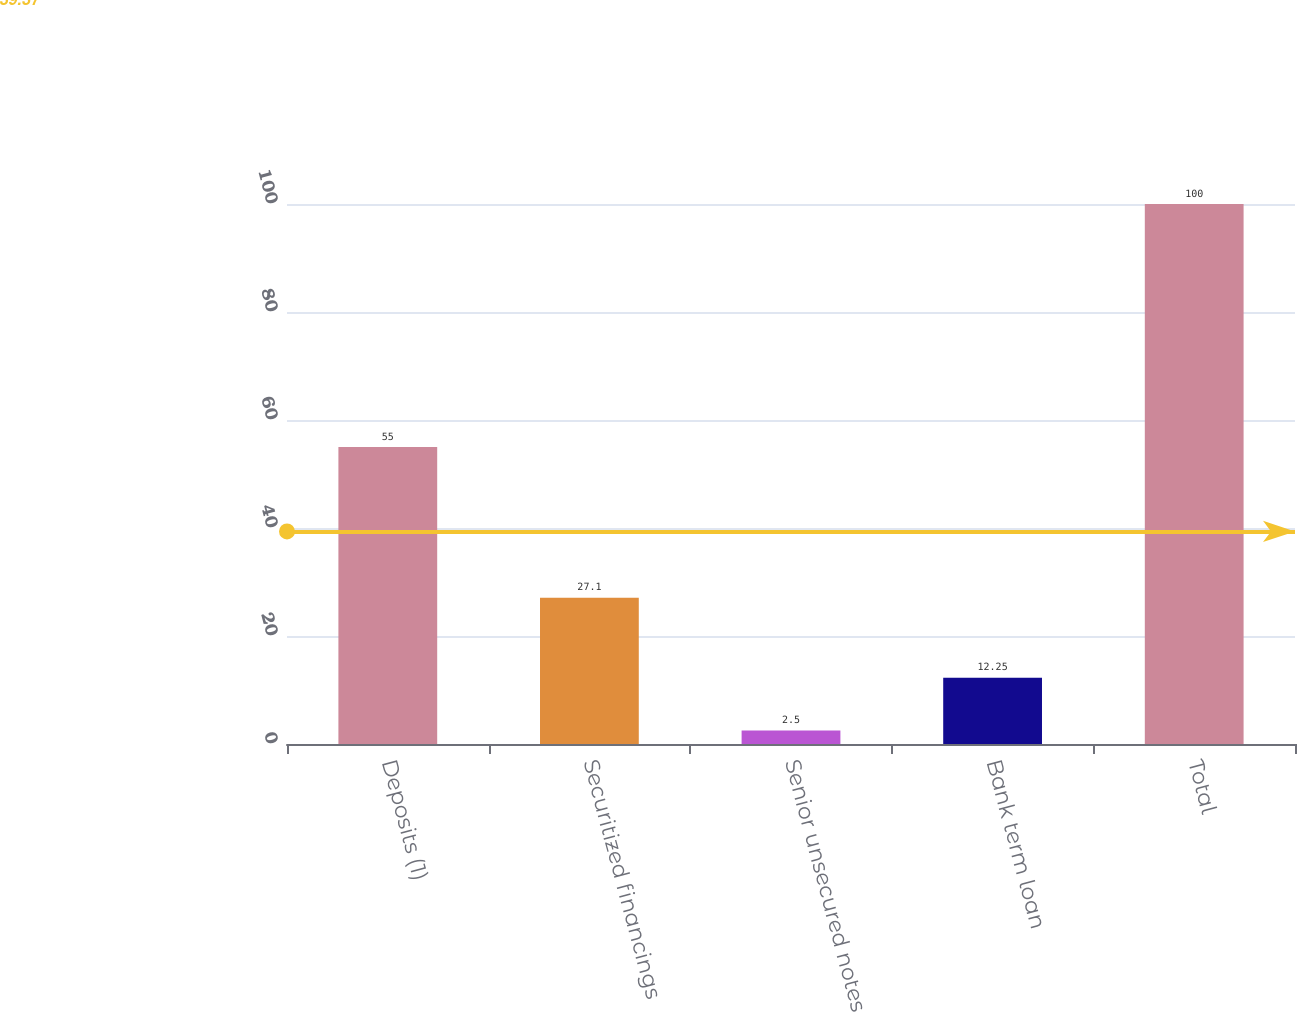Convert chart. <chart><loc_0><loc_0><loc_500><loc_500><bar_chart><fcel>Deposits (1)<fcel>Securitized financings<fcel>Senior unsecured notes<fcel>Bank term loan<fcel>Total<nl><fcel>55<fcel>27.1<fcel>2.5<fcel>12.25<fcel>100<nl></chart> 